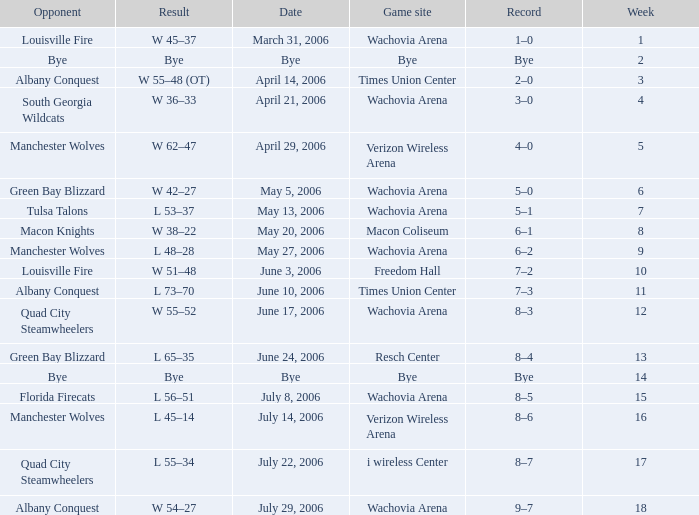What is the result for the game on May 27, 2006? L 48–28. 